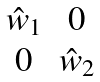<formula> <loc_0><loc_0><loc_500><loc_500>\begin{matrix} \hat { w } _ { 1 } & 0 \\ 0 & \hat { w } _ { 2 } \end{matrix}</formula> 